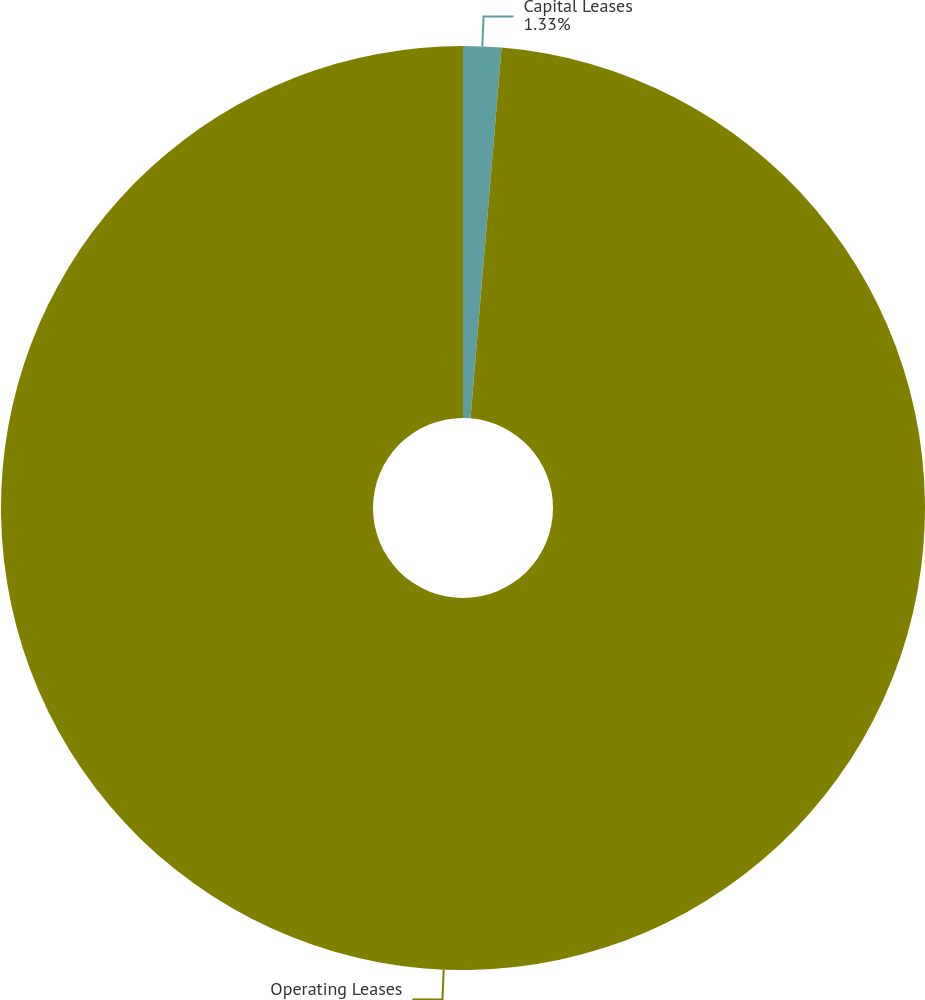Convert chart to OTSL. <chart><loc_0><loc_0><loc_500><loc_500><pie_chart><fcel>Capital Leases<fcel>Operating Leases<nl><fcel>1.33%<fcel>98.67%<nl></chart> 